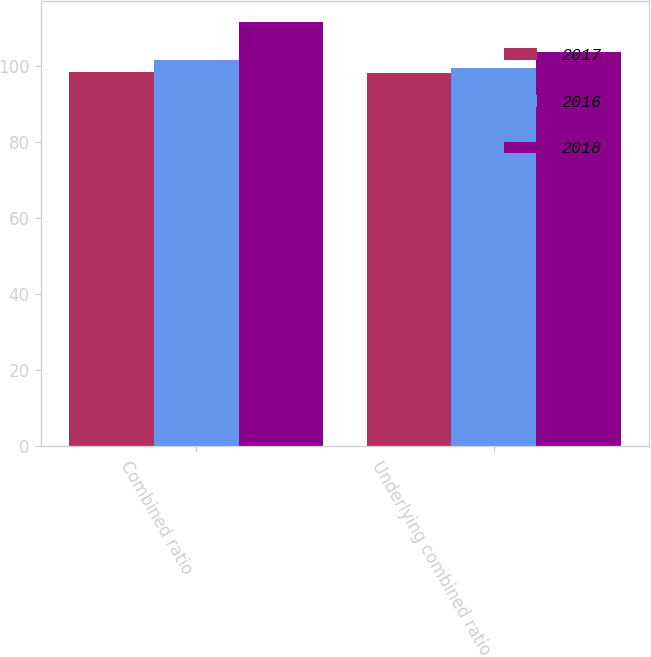Convert chart to OTSL. <chart><loc_0><loc_0><loc_500><loc_500><stacked_bar_chart><ecel><fcel>Combined ratio<fcel>Underlying combined ratio<nl><fcel>2017<fcel>98.6<fcel>98.2<nl><fcel>2016<fcel>101.6<fcel>99.7<nl><fcel>2018<fcel>111.6<fcel>103.9<nl></chart> 